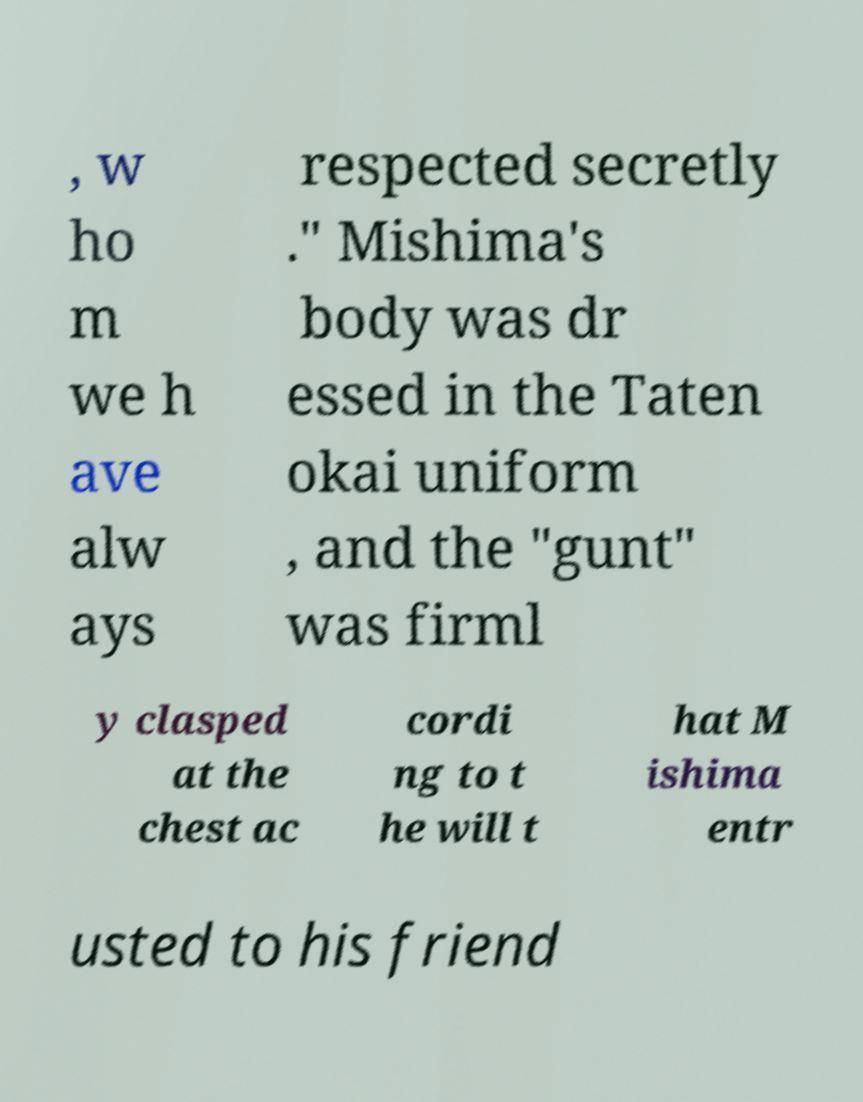Can you read and provide the text displayed in the image?This photo seems to have some interesting text. Can you extract and type it out for me? , w ho m we h ave alw ays respected secretly ." Mishima's body was dr essed in the Taten okai uniform , and the "gunt" was firml y clasped at the chest ac cordi ng to t he will t hat M ishima entr usted to his friend 